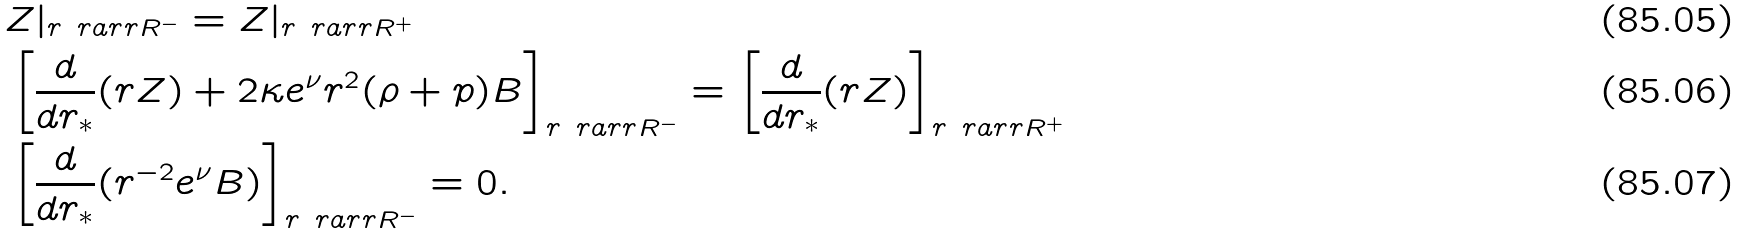Convert formula to latex. <formula><loc_0><loc_0><loc_500><loc_500>& Z | _ { r \ r a r r R ^ { - } } = Z | _ { r \ r a r r R ^ { + } } \\ & \left [ \frac { d } { d r _ { * } } ( r Z ) + 2 \kappa e ^ { \nu } r ^ { 2 } ( \rho + p ) B \right ] _ { r \ r a r r R ^ { - } } = \left [ \frac { d } { d r _ { * } } ( r Z ) \right ] _ { r \ r a r r R ^ { + } } \\ & \left [ \frac { d } { d r _ { * } } ( r ^ { - 2 } e ^ { \nu } B ) \right ] _ { r \ r a r r R ^ { - } } = 0 .</formula> 